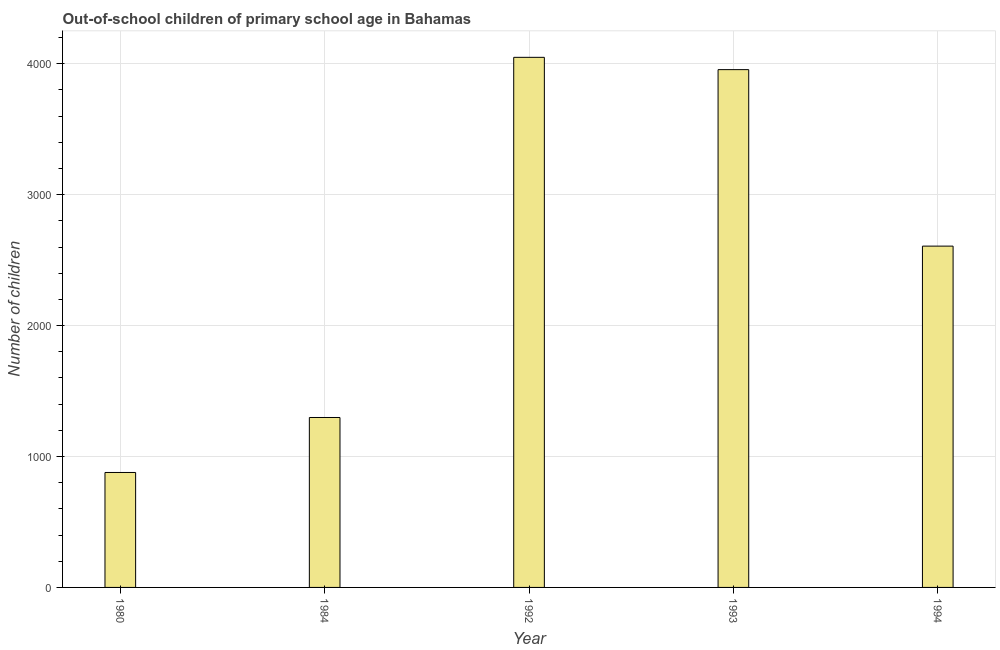Does the graph contain any zero values?
Provide a short and direct response. No. What is the title of the graph?
Keep it short and to the point. Out-of-school children of primary school age in Bahamas. What is the label or title of the Y-axis?
Provide a short and direct response. Number of children. What is the number of out-of-school children in 1994?
Your answer should be very brief. 2607. Across all years, what is the maximum number of out-of-school children?
Offer a very short reply. 4049. Across all years, what is the minimum number of out-of-school children?
Your response must be concise. 878. What is the sum of the number of out-of-school children?
Give a very brief answer. 1.28e+04. What is the difference between the number of out-of-school children in 1980 and 1992?
Ensure brevity in your answer.  -3171. What is the average number of out-of-school children per year?
Give a very brief answer. 2557. What is the median number of out-of-school children?
Give a very brief answer. 2607. In how many years, is the number of out-of-school children greater than 400 ?
Your answer should be compact. 5. What is the ratio of the number of out-of-school children in 1980 to that in 1984?
Offer a very short reply. 0.68. Is the difference between the number of out-of-school children in 1984 and 1993 greater than the difference between any two years?
Offer a very short reply. No. What is the difference between the highest and the second highest number of out-of-school children?
Give a very brief answer. 94. What is the difference between the highest and the lowest number of out-of-school children?
Make the answer very short. 3171. In how many years, is the number of out-of-school children greater than the average number of out-of-school children taken over all years?
Ensure brevity in your answer.  3. Are the values on the major ticks of Y-axis written in scientific E-notation?
Ensure brevity in your answer.  No. What is the Number of children of 1980?
Your response must be concise. 878. What is the Number of children of 1984?
Give a very brief answer. 1298. What is the Number of children in 1992?
Give a very brief answer. 4049. What is the Number of children of 1993?
Provide a short and direct response. 3955. What is the Number of children in 1994?
Keep it short and to the point. 2607. What is the difference between the Number of children in 1980 and 1984?
Offer a very short reply. -420. What is the difference between the Number of children in 1980 and 1992?
Ensure brevity in your answer.  -3171. What is the difference between the Number of children in 1980 and 1993?
Provide a succinct answer. -3077. What is the difference between the Number of children in 1980 and 1994?
Your answer should be compact. -1729. What is the difference between the Number of children in 1984 and 1992?
Offer a very short reply. -2751. What is the difference between the Number of children in 1984 and 1993?
Your answer should be compact. -2657. What is the difference between the Number of children in 1984 and 1994?
Make the answer very short. -1309. What is the difference between the Number of children in 1992 and 1993?
Ensure brevity in your answer.  94. What is the difference between the Number of children in 1992 and 1994?
Your response must be concise. 1442. What is the difference between the Number of children in 1993 and 1994?
Make the answer very short. 1348. What is the ratio of the Number of children in 1980 to that in 1984?
Ensure brevity in your answer.  0.68. What is the ratio of the Number of children in 1980 to that in 1992?
Give a very brief answer. 0.22. What is the ratio of the Number of children in 1980 to that in 1993?
Give a very brief answer. 0.22. What is the ratio of the Number of children in 1980 to that in 1994?
Ensure brevity in your answer.  0.34. What is the ratio of the Number of children in 1984 to that in 1992?
Offer a terse response. 0.32. What is the ratio of the Number of children in 1984 to that in 1993?
Offer a terse response. 0.33. What is the ratio of the Number of children in 1984 to that in 1994?
Offer a terse response. 0.5. What is the ratio of the Number of children in 1992 to that in 1994?
Offer a very short reply. 1.55. What is the ratio of the Number of children in 1993 to that in 1994?
Give a very brief answer. 1.52. 